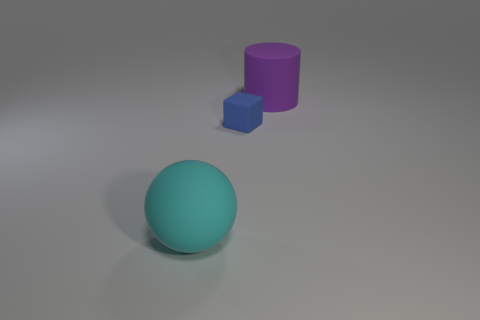Subtract all yellow cylinders. Subtract all red balls. How many cylinders are left? 1 Add 3 small shiny objects. How many objects exist? 6 Subtract all cylinders. How many objects are left? 2 Subtract 1 purple cylinders. How many objects are left? 2 Subtract all cyan rubber spheres. Subtract all blue blocks. How many objects are left? 1 Add 1 matte cylinders. How many matte cylinders are left? 2 Add 3 small blocks. How many small blocks exist? 4 